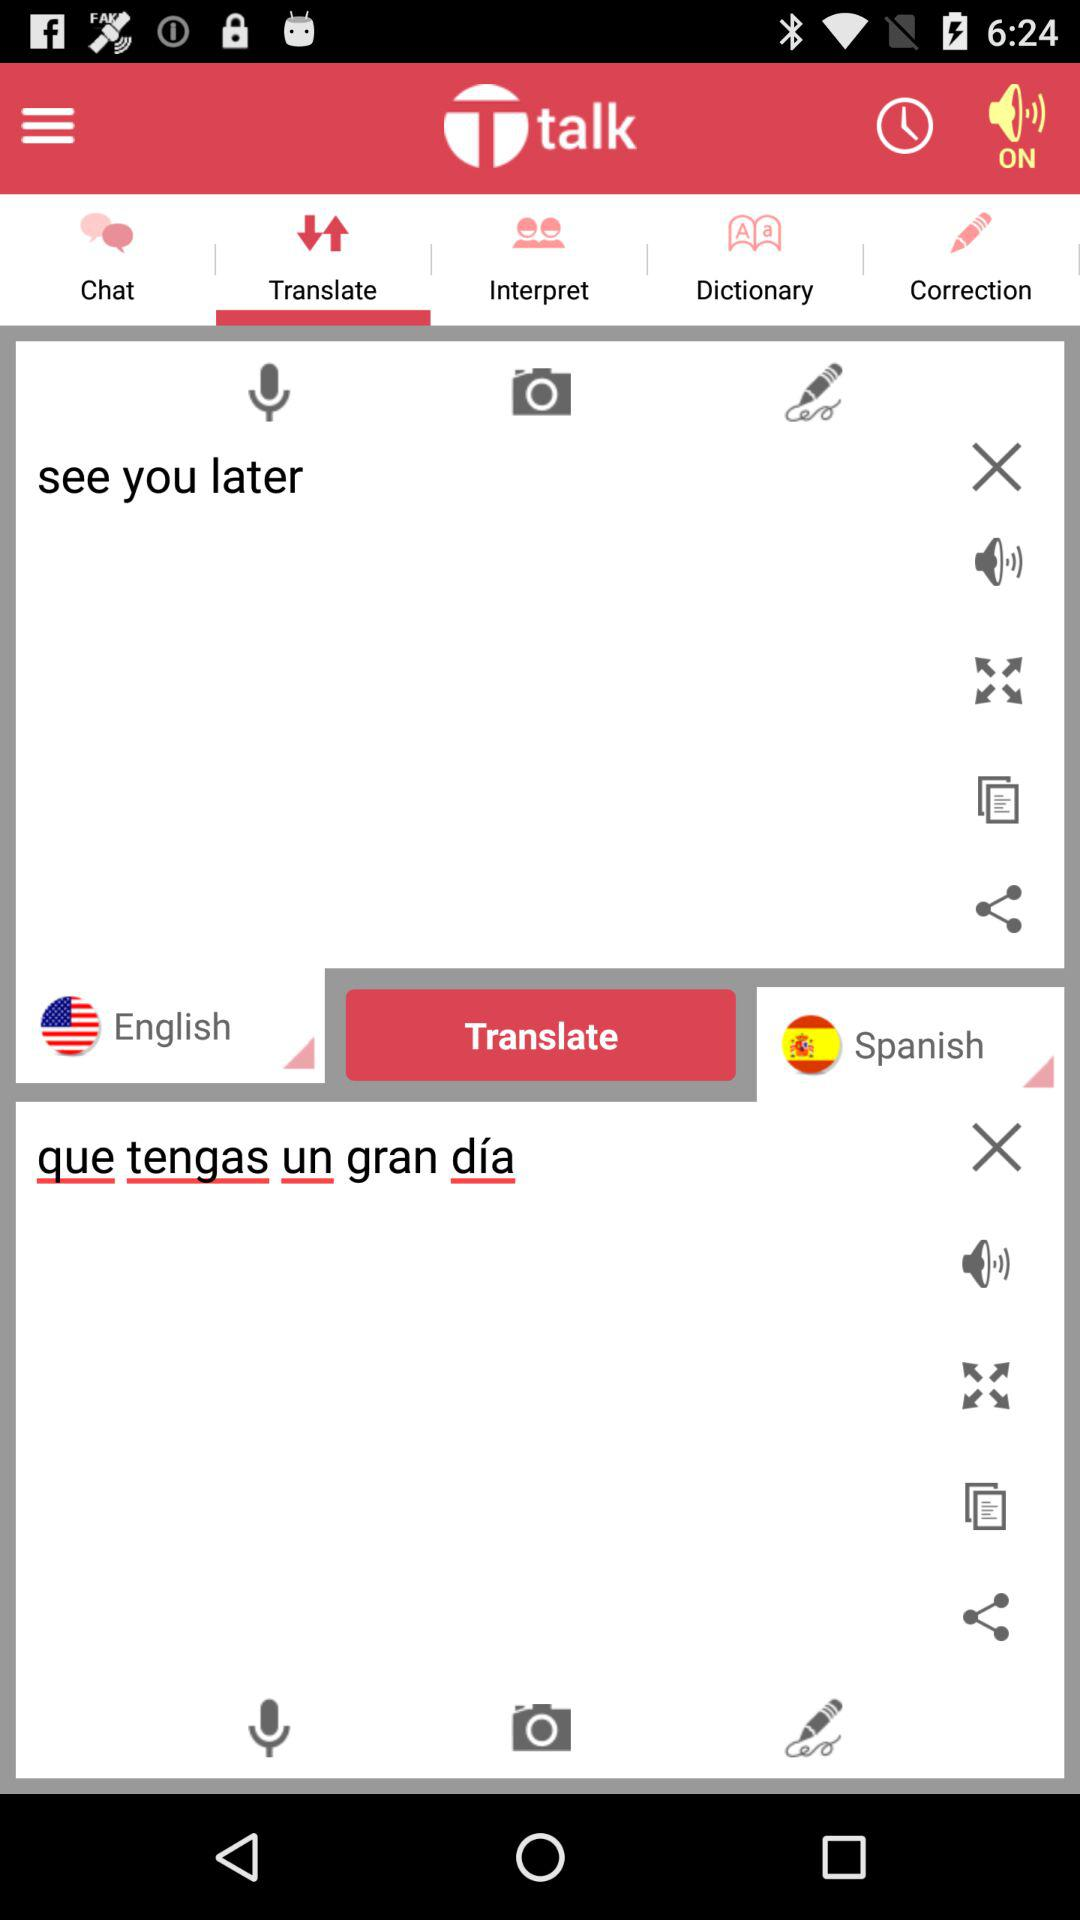What is the text that has been entered for translation? The text entered for translation is "see you later". 